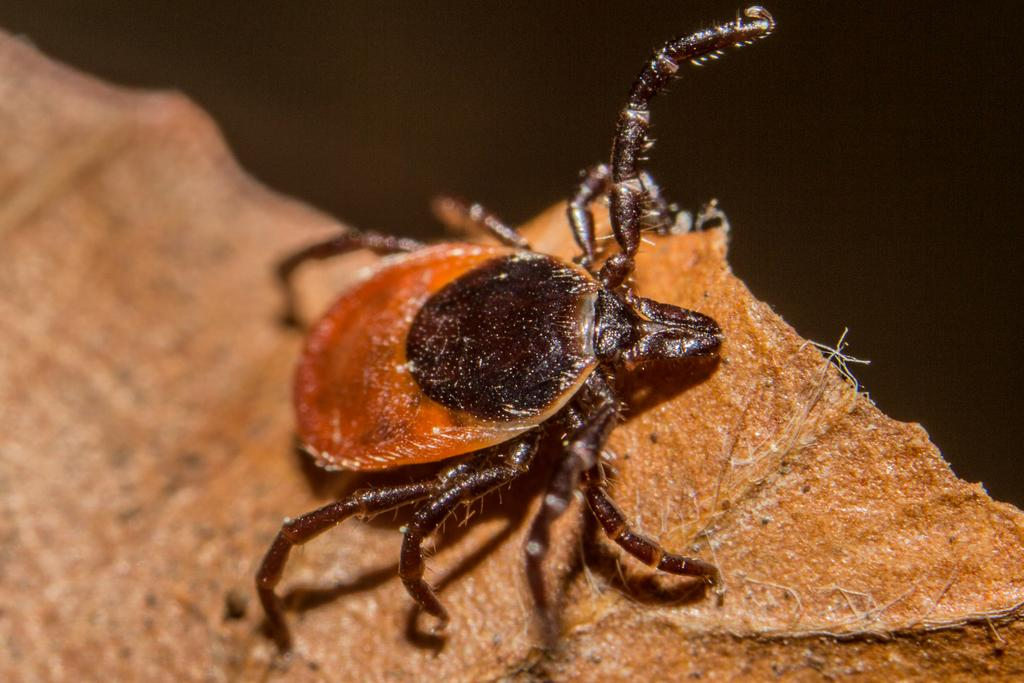What type of creature is present in the image? There is an insect in the image. What is the insect situated on? The insect is on an object. What is the color of the background in the image? The background of the image is dark. What type of building can be seen in the image? There is no building present in the image; it features an insect on an object. What is the insect eating for breakfast in the image? There is no indication in the image that the insect is eating breakfast, as insects do not typically consume human food. 